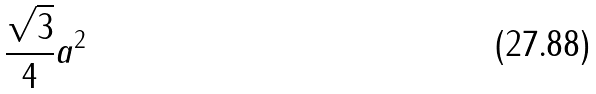<formula> <loc_0><loc_0><loc_500><loc_500>\frac { \sqrt { 3 } } { 4 } a ^ { 2 }</formula> 